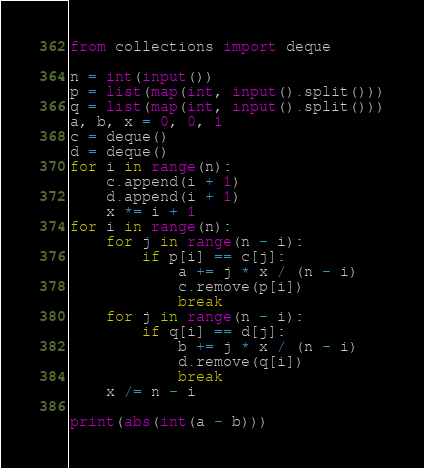<code> <loc_0><loc_0><loc_500><loc_500><_Python_>from collections import deque

n = int(input())
p = list(map(int, input().split()))
q = list(map(int, input().split()))
a, b, x = 0, 0, 1
c = deque()
d = deque()
for i in range(n):
    c.append(i + 1)
    d.append(i + 1)
    x *= i + 1
for i in range(n):
    for j in range(n - i):
        if p[i] == c[j]:
            a += j * x / (n - i)
            c.remove(p[i])
            break
    for j in range(n - i):
        if q[i] == d[j]:
            b += j * x / (n - i)
            d.remove(q[i])
            break
    x /= n - i

print(abs(int(a - b)))</code> 